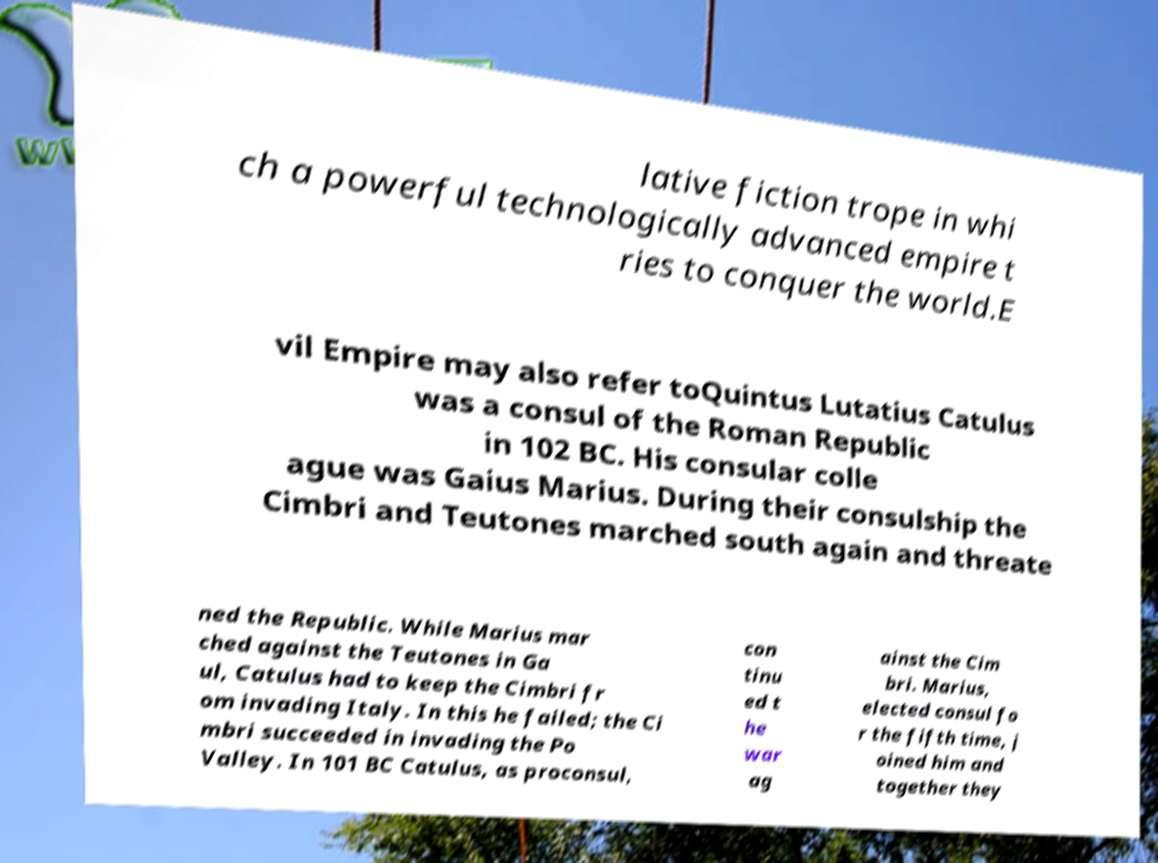What messages or text are displayed in this image? I need them in a readable, typed format. lative fiction trope in whi ch a powerful technologically advanced empire t ries to conquer the world.E vil Empire may also refer toQuintus Lutatius Catulus was a consul of the Roman Republic in 102 BC. His consular colle ague was Gaius Marius. During their consulship the Cimbri and Teutones marched south again and threate ned the Republic. While Marius mar ched against the Teutones in Ga ul, Catulus had to keep the Cimbri fr om invading Italy. In this he failed; the Ci mbri succeeded in invading the Po Valley. In 101 BC Catulus, as proconsul, con tinu ed t he war ag ainst the Cim bri. Marius, elected consul fo r the fifth time, j oined him and together they 